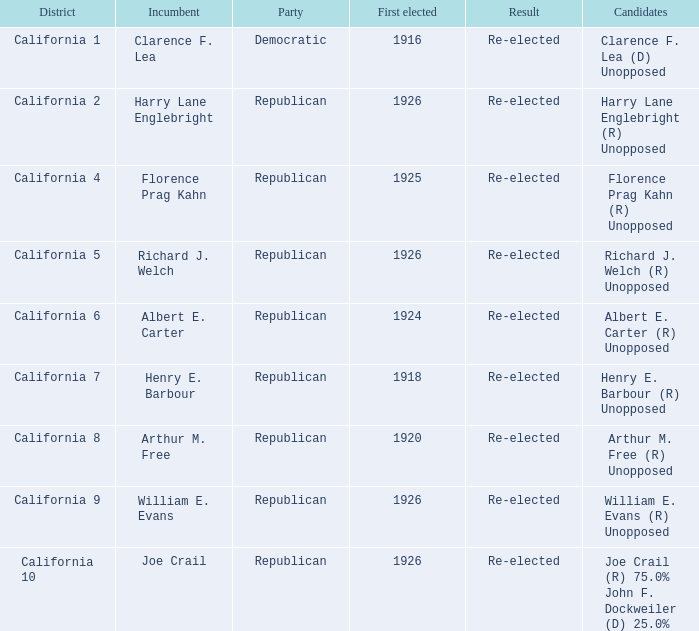What's the districtwith party being democratic California 1. 